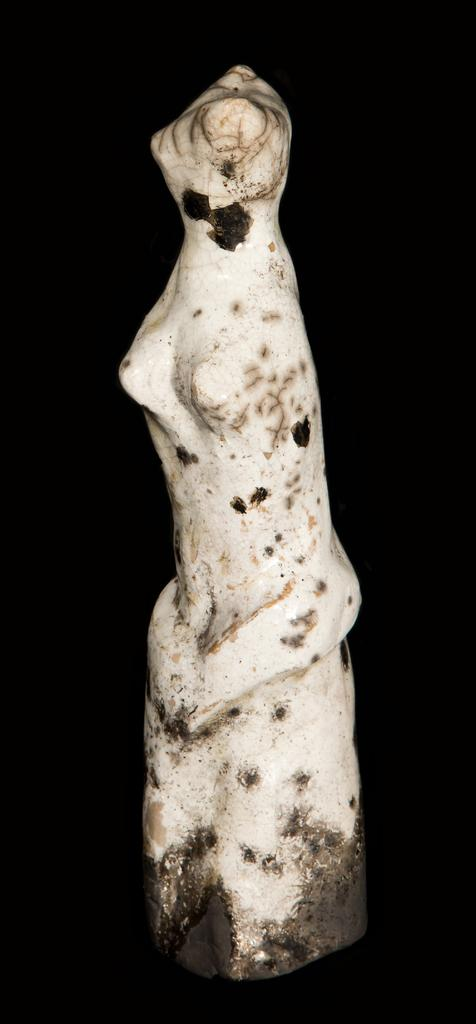What is the main subject of the picture? The main subject of the picture is a sculpture. What color is the background of the image? The background of the image is black in color. What type of education can be seen in the picture? There is no education present in the image; it features a sculpture and a black background. What type of spoon is visible in the picture? There is no spoon present in the image. What type of fire can be seen in the picture? There is no fire present in the image. 